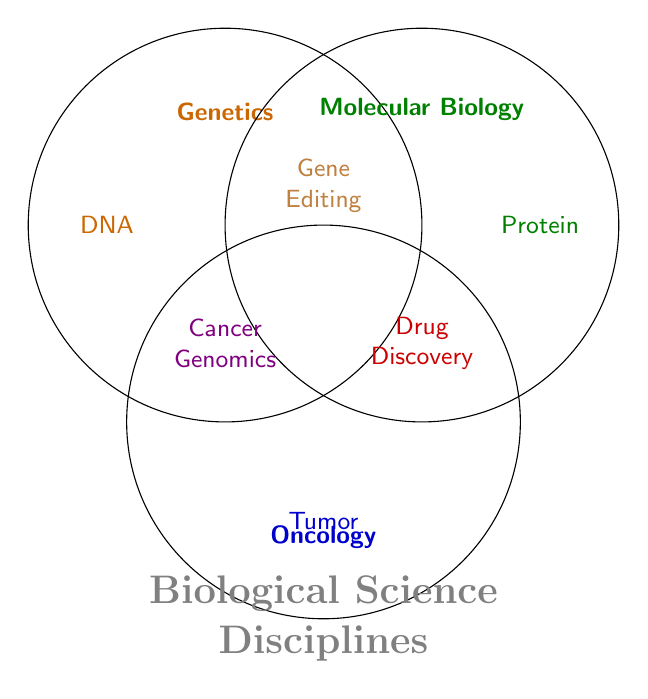What are the three main disciplines in the Venn Diagram? The three main disciplines are listed at the top of each circle in the Venn Diagram. They are Genetics, Molecular Biology, and Oncology.
Answer: Genetics, Molecular Biology, and Oncology Which category is shared by all three disciplines? The category located at the intersection of all three circles in the Venn Diagram represents the category shared by Genetics, Molecular Biology, and Oncology. This category is labeled as Cancer Genomics.
Answer: Cancer Genomics What categories are shared between Molecular Biology and Oncology? The categories located at the intersection of the Molecular Biology and Oncology circles represent those shared between these two disciplines. The diagram shows Drug Discovery and Cell Signaling in this intersection.
Answer: Drug Discovery and Cell Signaling Which category is unique to Genetics alone? The category positioned only within the Genetics circle and not overlapping with the other circles represents a unique category for Genetics. The diagram lists DNA in this section.
Answer: DNA Which discipline does Tumor Biology belong to? The category labeled as Tumor Biology is fully enclosed by the Oncology circle and does not overlap with Genetics or Molecular Biology.
Answer: Oncology What category is shared by Genetics and Molecular Biology but not Oncology? The categories located at the intersection of Genetics and Molecular Biology circles, but outside the Oncology circle, are shared by Genetics and Molecular Biology. The diagram lists Gene Editing and DNA Sequencing in this section.
Answer: Gene Editing and DNA Sequencing Which discipline does Protein Analysis belong to? Protein Analysis is located entirely within the Molecular Biology circle and does not overlap with Genetics or Oncology.
Answer: Molecular Biology Name a category shared by Genetics and Oncology. The intersection of the Genetics and Oncology circles contains the category Hereditary Cancer Syndromes.
Answer: Hereditary Cancer Syndromes Which two categories are entirely in the Oncology discipline? The categories located solely within the Oncology circle and not overlapping with the other circles are Tumor Biology and Immunotherapy.
Answer: Tumor Biology and Immunotherapy 